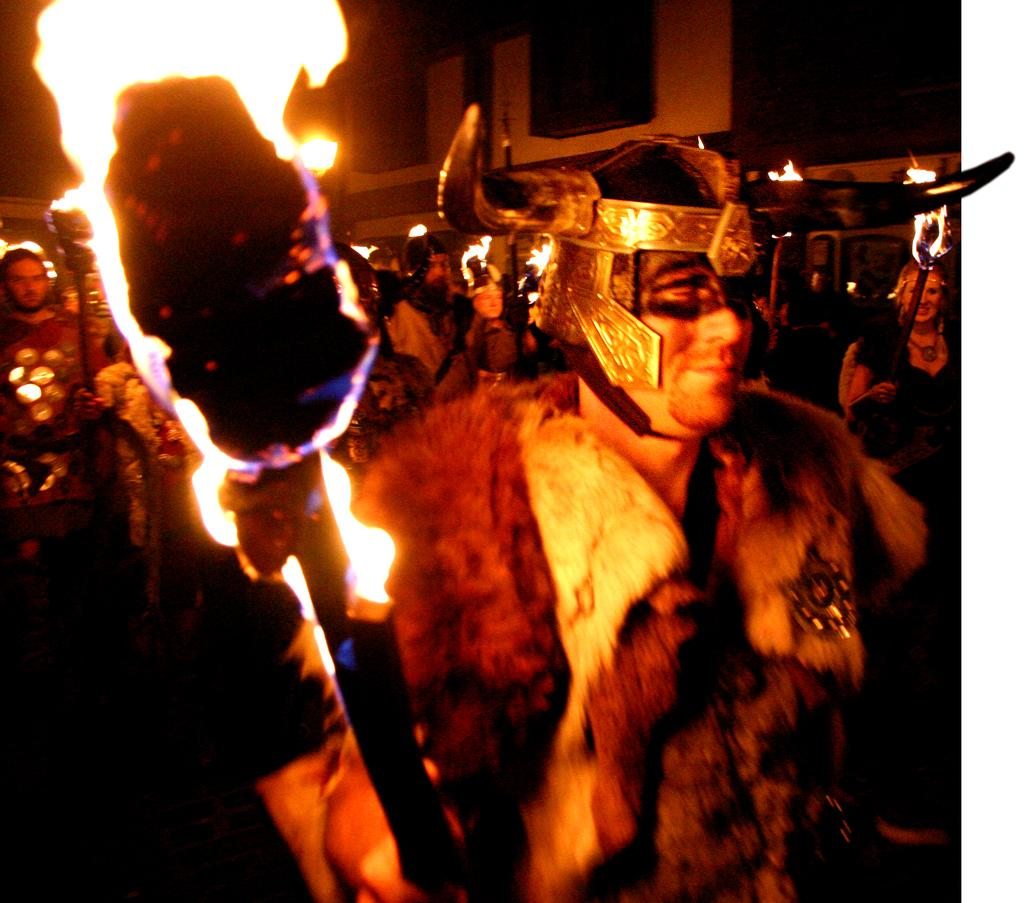How many people are in the image? There is a group of people in the image, but the exact number cannot be determined from the provided facts. What are the fire sticks used for in the image? The purpose of the fire sticks in the image cannot be determined from the provided facts. Can you describe any objects in the image? Yes, there are some objects in the image, but their specific nature cannot be determined from the provided facts. What can be seen in the background of the image? There is a building in the background of the image. What type of comb is being used to connect the route in the image? There is no comb, connection, or route present in the image. 